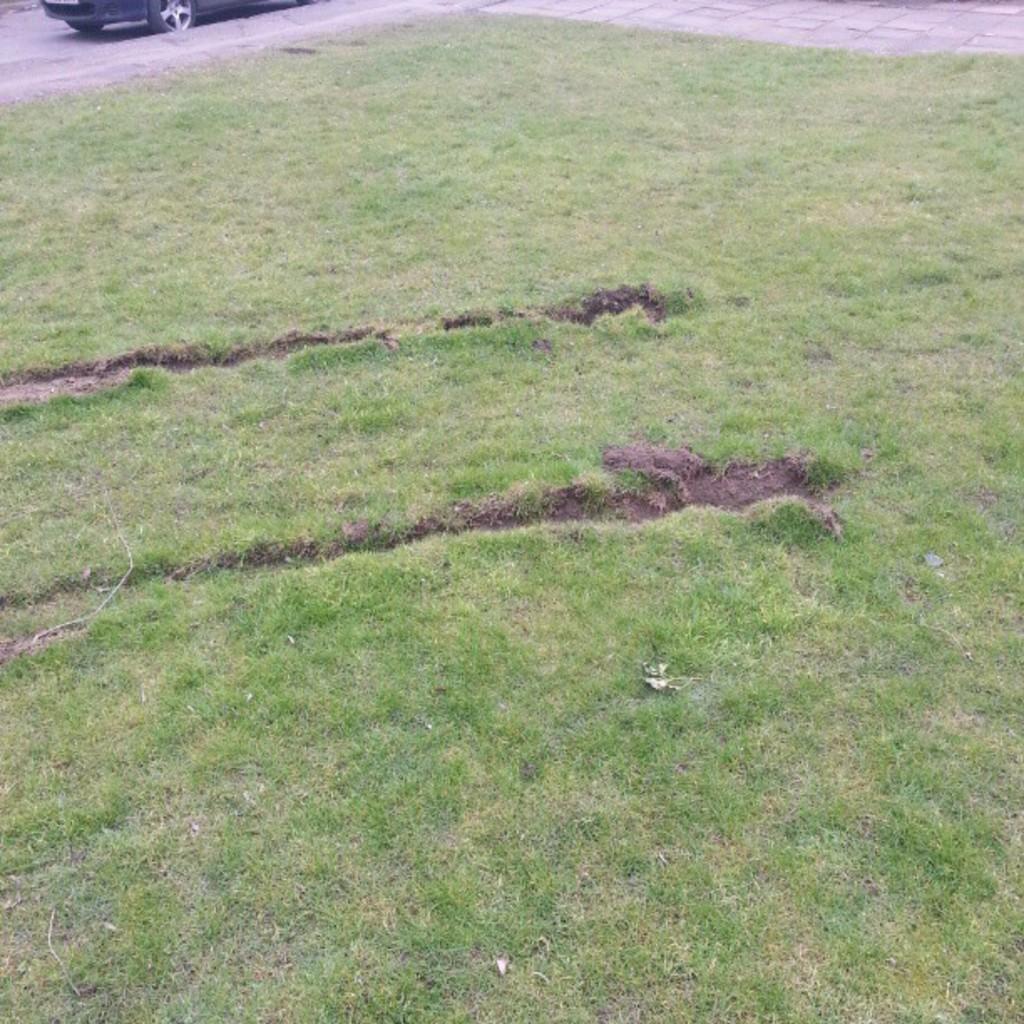Describe this image in one or two sentences. In this picture there is a vehicle on the road. In the foreground there is grass. 